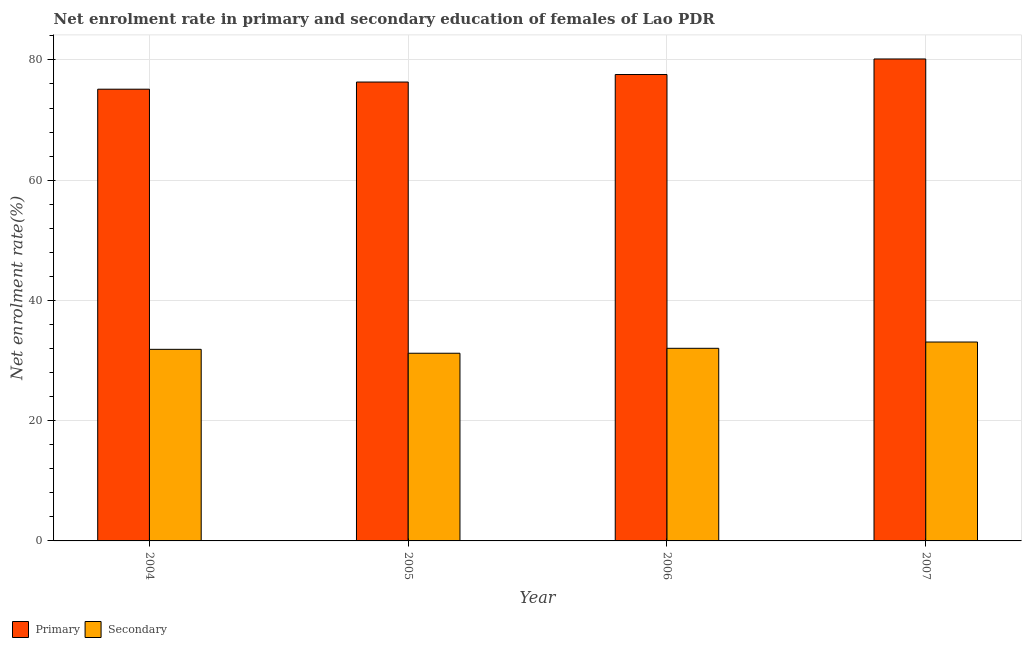How many different coloured bars are there?
Offer a very short reply. 2. Are the number of bars per tick equal to the number of legend labels?
Offer a terse response. Yes. Are the number of bars on each tick of the X-axis equal?
Offer a very short reply. Yes. How many bars are there on the 2nd tick from the left?
Keep it short and to the point. 2. What is the enrollment rate in secondary education in 2004?
Provide a succinct answer. 31.86. Across all years, what is the maximum enrollment rate in primary education?
Offer a terse response. 80.16. Across all years, what is the minimum enrollment rate in primary education?
Provide a succinct answer. 75.13. In which year was the enrollment rate in secondary education maximum?
Your answer should be very brief. 2007. In which year was the enrollment rate in primary education minimum?
Make the answer very short. 2004. What is the total enrollment rate in primary education in the graph?
Your response must be concise. 309.17. What is the difference between the enrollment rate in primary education in 2004 and that in 2006?
Make the answer very short. -2.44. What is the difference between the enrollment rate in primary education in 2005 and the enrollment rate in secondary education in 2007?
Your answer should be very brief. -3.84. What is the average enrollment rate in secondary education per year?
Offer a terse response. 32.05. In the year 2007, what is the difference between the enrollment rate in secondary education and enrollment rate in primary education?
Your answer should be very brief. 0. What is the ratio of the enrollment rate in secondary education in 2005 to that in 2007?
Your answer should be compact. 0.94. Is the difference between the enrollment rate in primary education in 2005 and 2006 greater than the difference between the enrollment rate in secondary education in 2005 and 2006?
Make the answer very short. No. What is the difference between the highest and the second highest enrollment rate in primary education?
Keep it short and to the point. 2.59. What is the difference between the highest and the lowest enrollment rate in primary education?
Provide a short and direct response. 5.03. Is the sum of the enrollment rate in secondary education in 2004 and 2006 greater than the maximum enrollment rate in primary education across all years?
Ensure brevity in your answer.  Yes. What does the 2nd bar from the left in 2007 represents?
Offer a terse response. Secondary. What does the 2nd bar from the right in 2004 represents?
Your answer should be compact. Primary. Are all the bars in the graph horizontal?
Ensure brevity in your answer.  No. How many years are there in the graph?
Give a very brief answer. 4. Are the values on the major ticks of Y-axis written in scientific E-notation?
Your answer should be very brief. No. Does the graph contain grids?
Make the answer very short. Yes. Where does the legend appear in the graph?
Give a very brief answer. Bottom left. How are the legend labels stacked?
Offer a very short reply. Horizontal. What is the title of the graph?
Offer a very short reply. Net enrolment rate in primary and secondary education of females of Lao PDR. What is the label or title of the Y-axis?
Ensure brevity in your answer.  Net enrolment rate(%). What is the Net enrolment rate(%) of Primary in 2004?
Give a very brief answer. 75.13. What is the Net enrolment rate(%) in Secondary in 2004?
Keep it short and to the point. 31.86. What is the Net enrolment rate(%) in Primary in 2005?
Your answer should be compact. 76.32. What is the Net enrolment rate(%) of Secondary in 2005?
Provide a succinct answer. 31.21. What is the Net enrolment rate(%) of Primary in 2006?
Make the answer very short. 77.57. What is the Net enrolment rate(%) of Secondary in 2006?
Your answer should be very brief. 32.04. What is the Net enrolment rate(%) in Primary in 2007?
Your answer should be compact. 80.16. What is the Net enrolment rate(%) of Secondary in 2007?
Provide a succinct answer. 33.08. Across all years, what is the maximum Net enrolment rate(%) in Primary?
Make the answer very short. 80.16. Across all years, what is the maximum Net enrolment rate(%) in Secondary?
Your answer should be very brief. 33.08. Across all years, what is the minimum Net enrolment rate(%) of Primary?
Ensure brevity in your answer.  75.13. Across all years, what is the minimum Net enrolment rate(%) in Secondary?
Give a very brief answer. 31.21. What is the total Net enrolment rate(%) of Primary in the graph?
Make the answer very short. 309.17. What is the total Net enrolment rate(%) of Secondary in the graph?
Keep it short and to the point. 128.19. What is the difference between the Net enrolment rate(%) of Primary in 2004 and that in 2005?
Ensure brevity in your answer.  -1.19. What is the difference between the Net enrolment rate(%) of Secondary in 2004 and that in 2005?
Offer a very short reply. 0.65. What is the difference between the Net enrolment rate(%) of Primary in 2004 and that in 2006?
Provide a short and direct response. -2.44. What is the difference between the Net enrolment rate(%) in Secondary in 2004 and that in 2006?
Give a very brief answer. -0.17. What is the difference between the Net enrolment rate(%) of Primary in 2004 and that in 2007?
Provide a succinct answer. -5.03. What is the difference between the Net enrolment rate(%) of Secondary in 2004 and that in 2007?
Your response must be concise. -1.22. What is the difference between the Net enrolment rate(%) of Primary in 2005 and that in 2006?
Keep it short and to the point. -1.25. What is the difference between the Net enrolment rate(%) of Secondary in 2005 and that in 2006?
Keep it short and to the point. -0.82. What is the difference between the Net enrolment rate(%) in Primary in 2005 and that in 2007?
Provide a succinct answer. -3.84. What is the difference between the Net enrolment rate(%) in Secondary in 2005 and that in 2007?
Your response must be concise. -1.87. What is the difference between the Net enrolment rate(%) in Primary in 2006 and that in 2007?
Keep it short and to the point. -2.59. What is the difference between the Net enrolment rate(%) of Secondary in 2006 and that in 2007?
Provide a succinct answer. -1.04. What is the difference between the Net enrolment rate(%) of Primary in 2004 and the Net enrolment rate(%) of Secondary in 2005?
Your answer should be very brief. 43.91. What is the difference between the Net enrolment rate(%) in Primary in 2004 and the Net enrolment rate(%) in Secondary in 2006?
Provide a succinct answer. 43.09. What is the difference between the Net enrolment rate(%) of Primary in 2004 and the Net enrolment rate(%) of Secondary in 2007?
Your response must be concise. 42.05. What is the difference between the Net enrolment rate(%) of Primary in 2005 and the Net enrolment rate(%) of Secondary in 2006?
Your answer should be very brief. 44.28. What is the difference between the Net enrolment rate(%) of Primary in 2005 and the Net enrolment rate(%) of Secondary in 2007?
Offer a terse response. 43.24. What is the difference between the Net enrolment rate(%) of Primary in 2006 and the Net enrolment rate(%) of Secondary in 2007?
Offer a very short reply. 44.49. What is the average Net enrolment rate(%) in Primary per year?
Keep it short and to the point. 77.29. What is the average Net enrolment rate(%) of Secondary per year?
Give a very brief answer. 32.05. In the year 2004, what is the difference between the Net enrolment rate(%) in Primary and Net enrolment rate(%) in Secondary?
Ensure brevity in your answer.  43.27. In the year 2005, what is the difference between the Net enrolment rate(%) of Primary and Net enrolment rate(%) of Secondary?
Keep it short and to the point. 45.11. In the year 2006, what is the difference between the Net enrolment rate(%) in Primary and Net enrolment rate(%) in Secondary?
Make the answer very short. 45.53. In the year 2007, what is the difference between the Net enrolment rate(%) in Primary and Net enrolment rate(%) in Secondary?
Your answer should be very brief. 47.08. What is the ratio of the Net enrolment rate(%) in Primary in 2004 to that in 2005?
Your answer should be compact. 0.98. What is the ratio of the Net enrolment rate(%) of Secondary in 2004 to that in 2005?
Provide a succinct answer. 1.02. What is the ratio of the Net enrolment rate(%) in Primary in 2004 to that in 2006?
Your answer should be compact. 0.97. What is the ratio of the Net enrolment rate(%) in Primary in 2004 to that in 2007?
Your answer should be very brief. 0.94. What is the ratio of the Net enrolment rate(%) of Secondary in 2004 to that in 2007?
Your answer should be very brief. 0.96. What is the ratio of the Net enrolment rate(%) of Primary in 2005 to that in 2006?
Your answer should be very brief. 0.98. What is the ratio of the Net enrolment rate(%) in Secondary in 2005 to that in 2006?
Provide a succinct answer. 0.97. What is the ratio of the Net enrolment rate(%) in Primary in 2005 to that in 2007?
Your answer should be very brief. 0.95. What is the ratio of the Net enrolment rate(%) of Secondary in 2005 to that in 2007?
Keep it short and to the point. 0.94. What is the ratio of the Net enrolment rate(%) in Primary in 2006 to that in 2007?
Make the answer very short. 0.97. What is the ratio of the Net enrolment rate(%) in Secondary in 2006 to that in 2007?
Ensure brevity in your answer.  0.97. What is the difference between the highest and the second highest Net enrolment rate(%) of Primary?
Make the answer very short. 2.59. What is the difference between the highest and the second highest Net enrolment rate(%) of Secondary?
Ensure brevity in your answer.  1.04. What is the difference between the highest and the lowest Net enrolment rate(%) of Primary?
Offer a very short reply. 5.03. What is the difference between the highest and the lowest Net enrolment rate(%) of Secondary?
Ensure brevity in your answer.  1.87. 